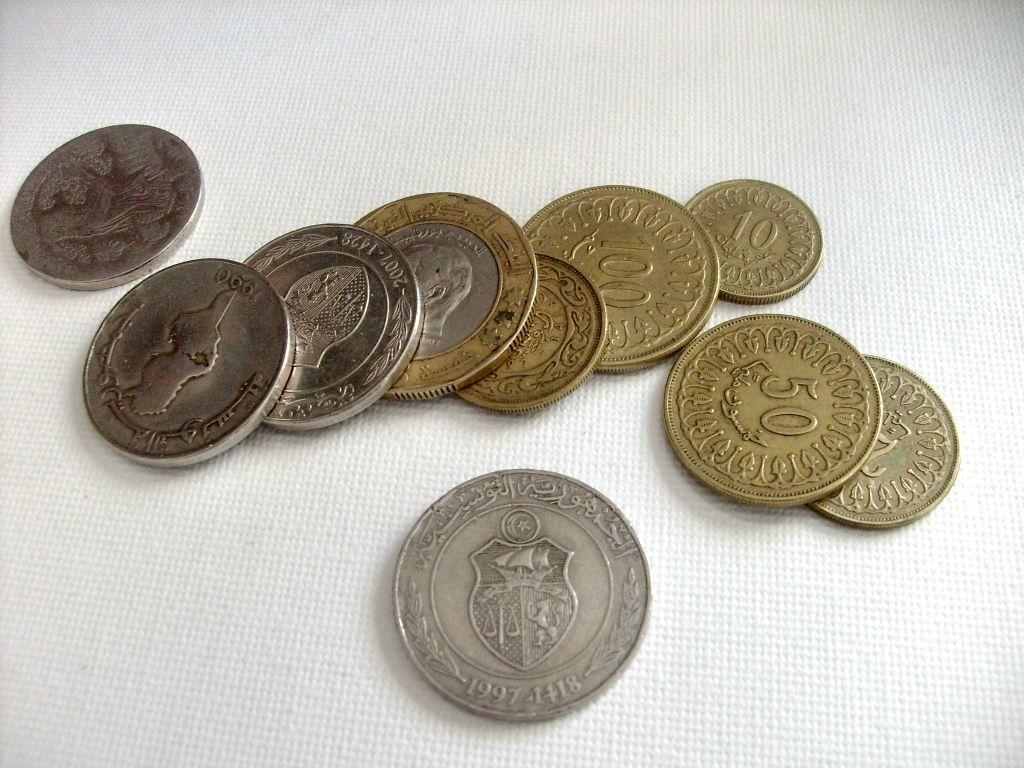What year is written on the silver coin at the bottom?
Your answer should be compact. 1997. What is written on the right side gold coin?
Offer a very short reply. 50. 